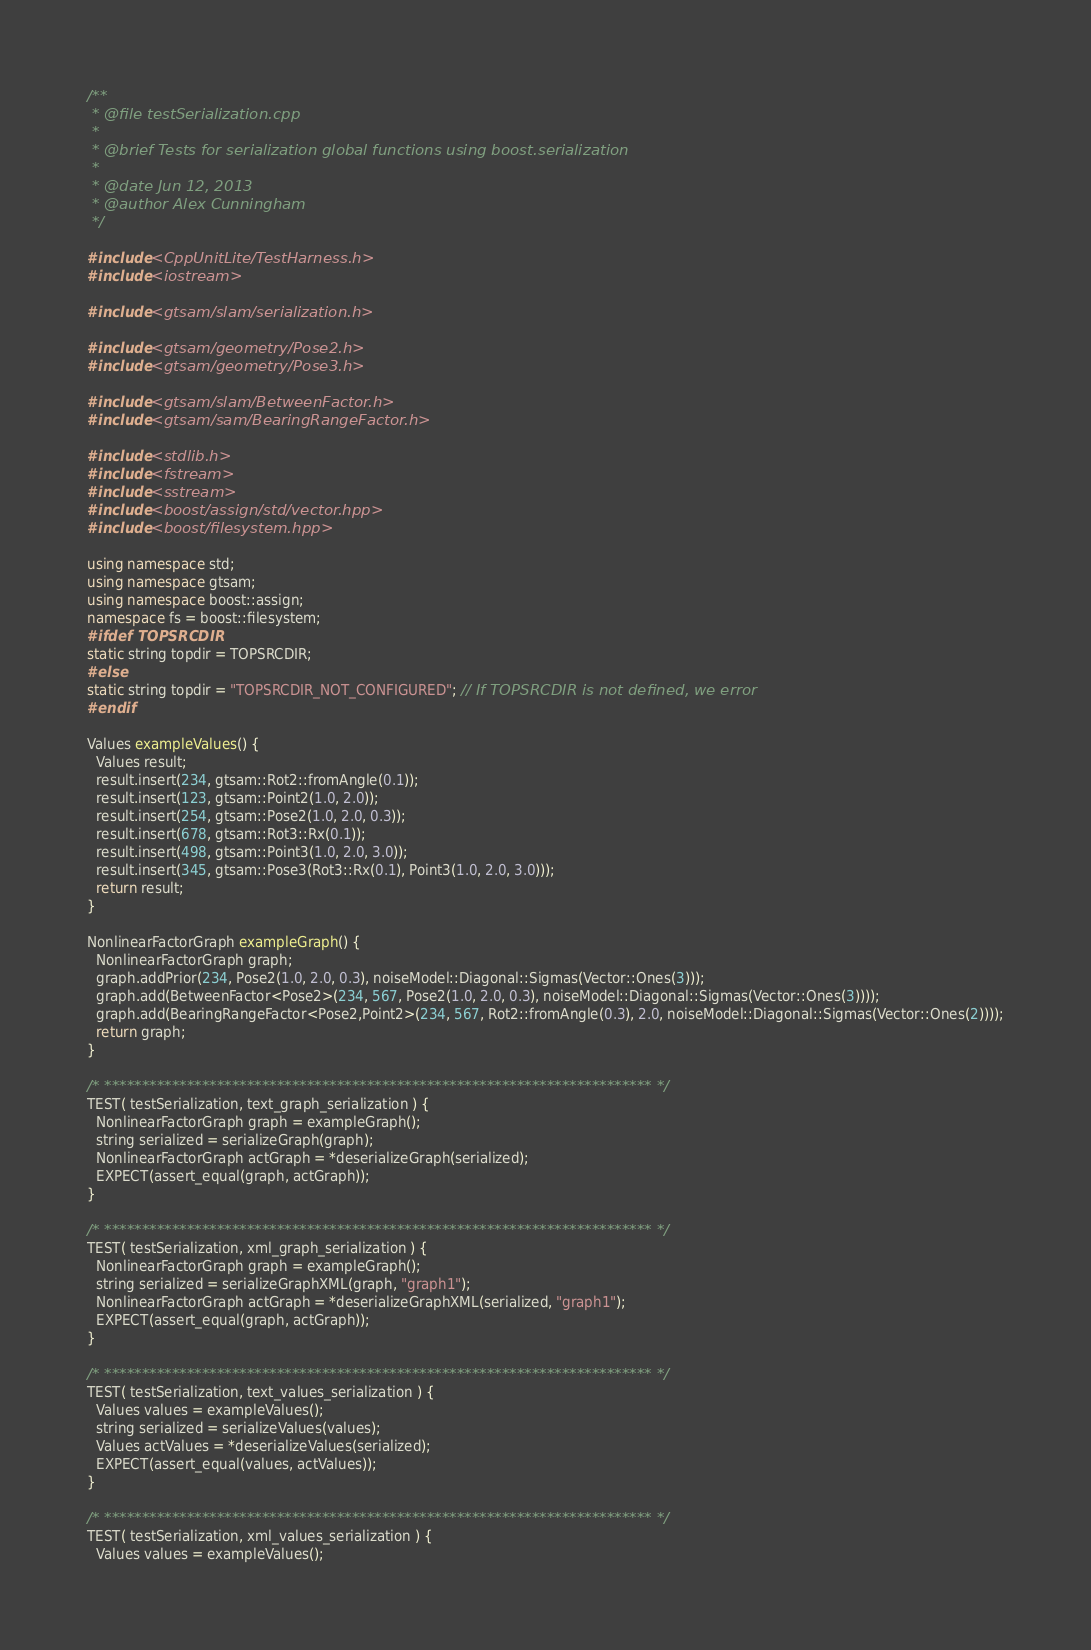Convert code to text. <code><loc_0><loc_0><loc_500><loc_500><_C++_>/**
 * @file testSerialization.cpp
 *
 * @brief Tests for serialization global functions using boost.serialization
 *
 * @date Jun 12, 2013
 * @author Alex Cunningham
 */

#include <CppUnitLite/TestHarness.h>
#include <iostream>

#include <gtsam/slam/serialization.h>

#include <gtsam/geometry/Pose2.h>
#include <gtsam/geometry/Pose3.h>

#include <gtsam/slam/BetweenFactor.h>
#include <gtsam/sam/BearingRangeFactor.h>

#include <stdlib.h>
#include <fstream>
#include <sstream>
#include <boost/assign/std/vector.hpp>
#include <boost/filesystem.hpp>

using namespace std;
using namespace gtsam;
using namespace boost::assign;
namespace fs = boost::filesystem;
#ifdef TOPSRCDIR
static string topdir = TOPSRCDIR;
#else
static string topdir = "TOPSRCDIR_NOT_CONFIGURED"; // If TOPSRCDIR is not defined, we error
#endif

Values exampleValues() {
  Values result;
  result.insert(234, gtsam::Rot2::fromAngle(0.1));
  result.insert(123, gtsam::Point2(1.0, 2.0));
  result.insert(254, gtsam::Pose2(1.0, 2.0, 0.3));
  result.insert(678, gtsam::Rot3::Rx(0.1));
  result.insert(498, gtsam::Point3(1.0, 2.0, 3.0));
  result.insert(345, gtsam::Pose3(Rot3::Rx(0.1), Point3(1.0, 2.0, 3.0)));
  return result;
}

NonlinearFactorGraph exampleGraph() {
  NonlinearFactorGraph graph;
  graph.addPrior(234, Pose2(1.0, 2.0, 0.3), noiseModel::Diagonal::Sigmas(Vector::Ones(3)));
  graph.add(BetweenFactor<Pose2>(234, 567, Pose2(1.0, 2.0, 0.3), noiseModel::Diagonal::Sigmas(Vector::Ones(3))));
  graph.add(BearingRangeFactor<Pose2,Point2>(234, 567, Rot2::fromAngle(0.3), 2.0, noiseModel::Diagonal::Sigmas(Vector::Ones(2))));
  return graph;
}

/* ************************************************************************* */
TEST( testSerialization, text_graph_serialization ) {
  NonlinearFactorGraph graph = exampleGraph();
  string serialized = serializeGraph(graph);
  NonlinearFactorGraph actGraph = *deserializeGraph(serialized);
  EXPECT(assert_equal(graph, actGraph));
}

/* ************************************************************************* */
TEST( testSerialization, xml_graph_serialization ) {
  NonlinearFactorGraph graph = exampleGraph();
  string serialized = serializeGraphXML(graph, "graph1");
  NonlinearFactorGraph actGraph = *deserializeGraphXML(serialized, "graph1");
  EXPECT(assert_equal(graph, actGraph));
}

/* ************************************************************************* */
TEST( testSerialization, text_values_serialization ) {
  Values values = exampleValues();
  string serialized = serializeValues(values);
  Values actValues = *deserializeValues(serialized);
  EXPECT(assert_equal(values, actValues));
}

/* ************************************************************************* */
TEST( testSerialization, xml_values_serialization ) {
  Values values = exampleValues();</code> 